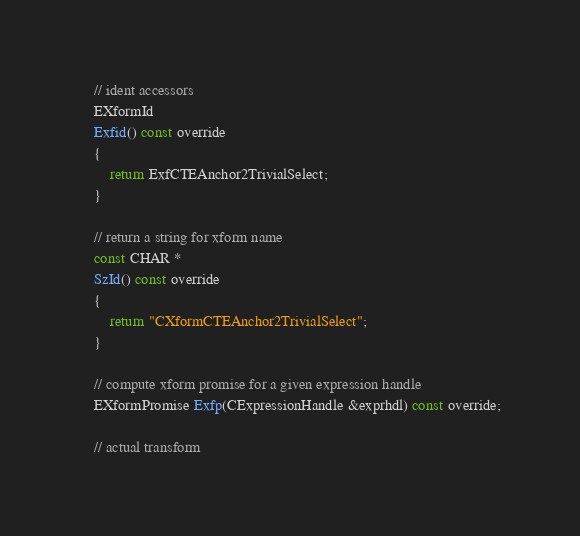Convert code to text. <code><loc_0><loc_0><loc_500><loc_500><_C_>	// ident accessors
	EXformId
	Exfid() const override
	{
		return ExfCTEAnchor2TrivialSelect;
	}

	// return a string for xform name
	const CHAR *
	SzId() const override
	{
		return "CXformCTEAnchor2TrivialSelect";
	}

	// compute xform promise for a given expression handle
	EXformPromise Exfp(CExpressionHandle &exprhdl) const override;

	// actual transform</code> 